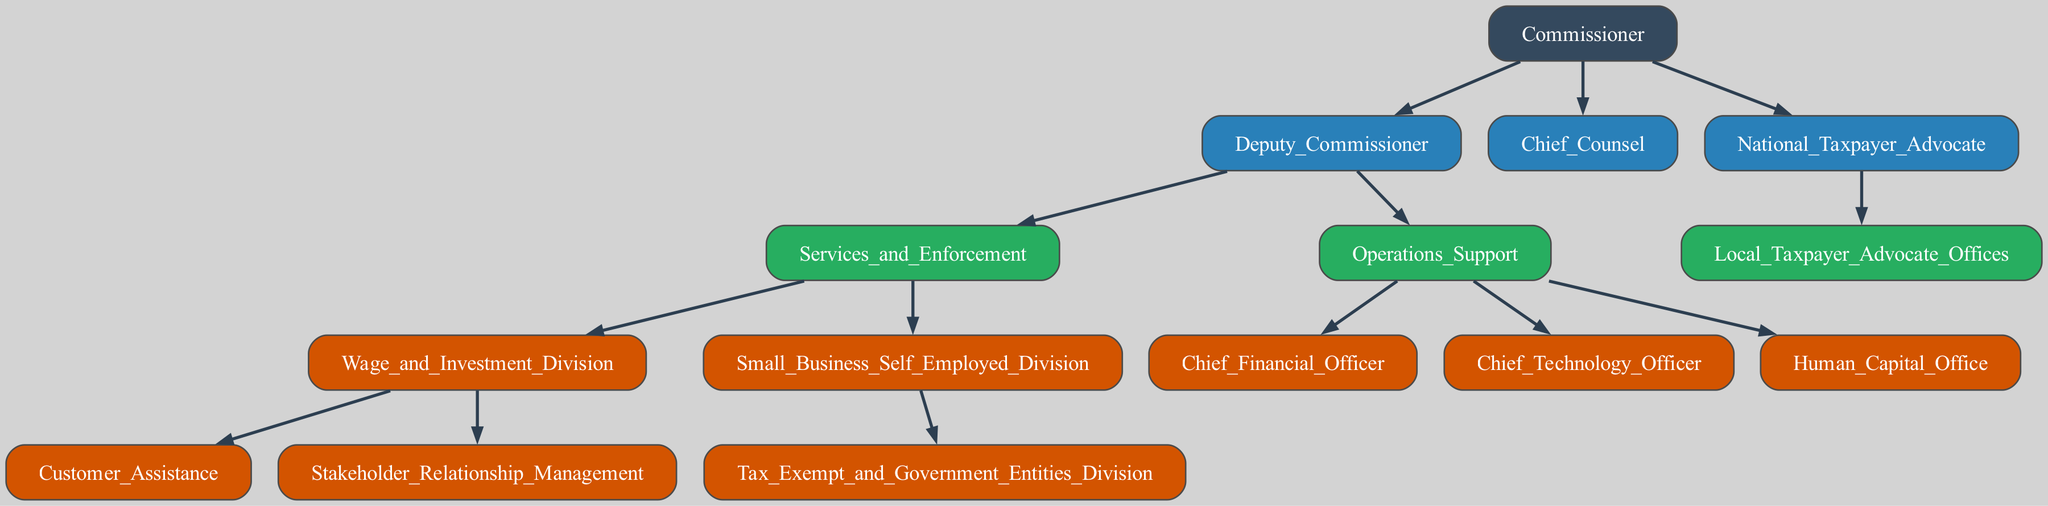What is the top-level position in the IRS structure? The top-level position is the Commissioner, who is the highest authority in the IRS structure.
Answer: Commissioner How many divisions report to the Deputy Commissioner? The Deputy Commissioner oversees two major divisions: Services and Enforcement, and Operations Support, which gives a total of two divisions.
Answer: 2 Which division is responsible for Tax Exempt and Government Entities? The Tax Exempt and Government Entities Division falls under the Small Business Self-Employed Division, indicating its specialized function regarding tax regulations for non-profit and government entities.
Answer: Small Business Self Employed Division What is the main role of the National Taxpayer Advocate? The National Taxpayer Advocate's primary role is to represent taxpayers' interests within the IRS and ensure that their voices are heard, as reflected in the structure.
Answer: Advocate How many offices are under the National Taxpayer Advocate? The National Taxpayer Advocate has one office specifically listed, which is the Local Taxpayer Advocate Offices.
Answer: 1 What are the two primary roles of the Deputy Commissioner? The Deputy Commissioner has two primary roles: overseeing Services and Enforcement, and providing Operations Support.
Answer: Services and Enforcement, Operations Support What position is directly under the Commissioner besides the Deputy Commissioner? The Chief Counsel is the position that directly reports to the Commissioner, serving as the IRS's legal advisor.
Answer: Chief Counsel Which officer is associated with financial matters in the IRS? The Chief Financial Officer is the officer associated with financial matters, indicating responsibility for the IRS's budget and financial operations.
Answer: Chief Financial Officer What department handles Customer Assistance? The Wage and Investment Division is responsible for Customer Assistance, providing support primarily to individual taxpayers.
Answer: Wage and Investment Division 